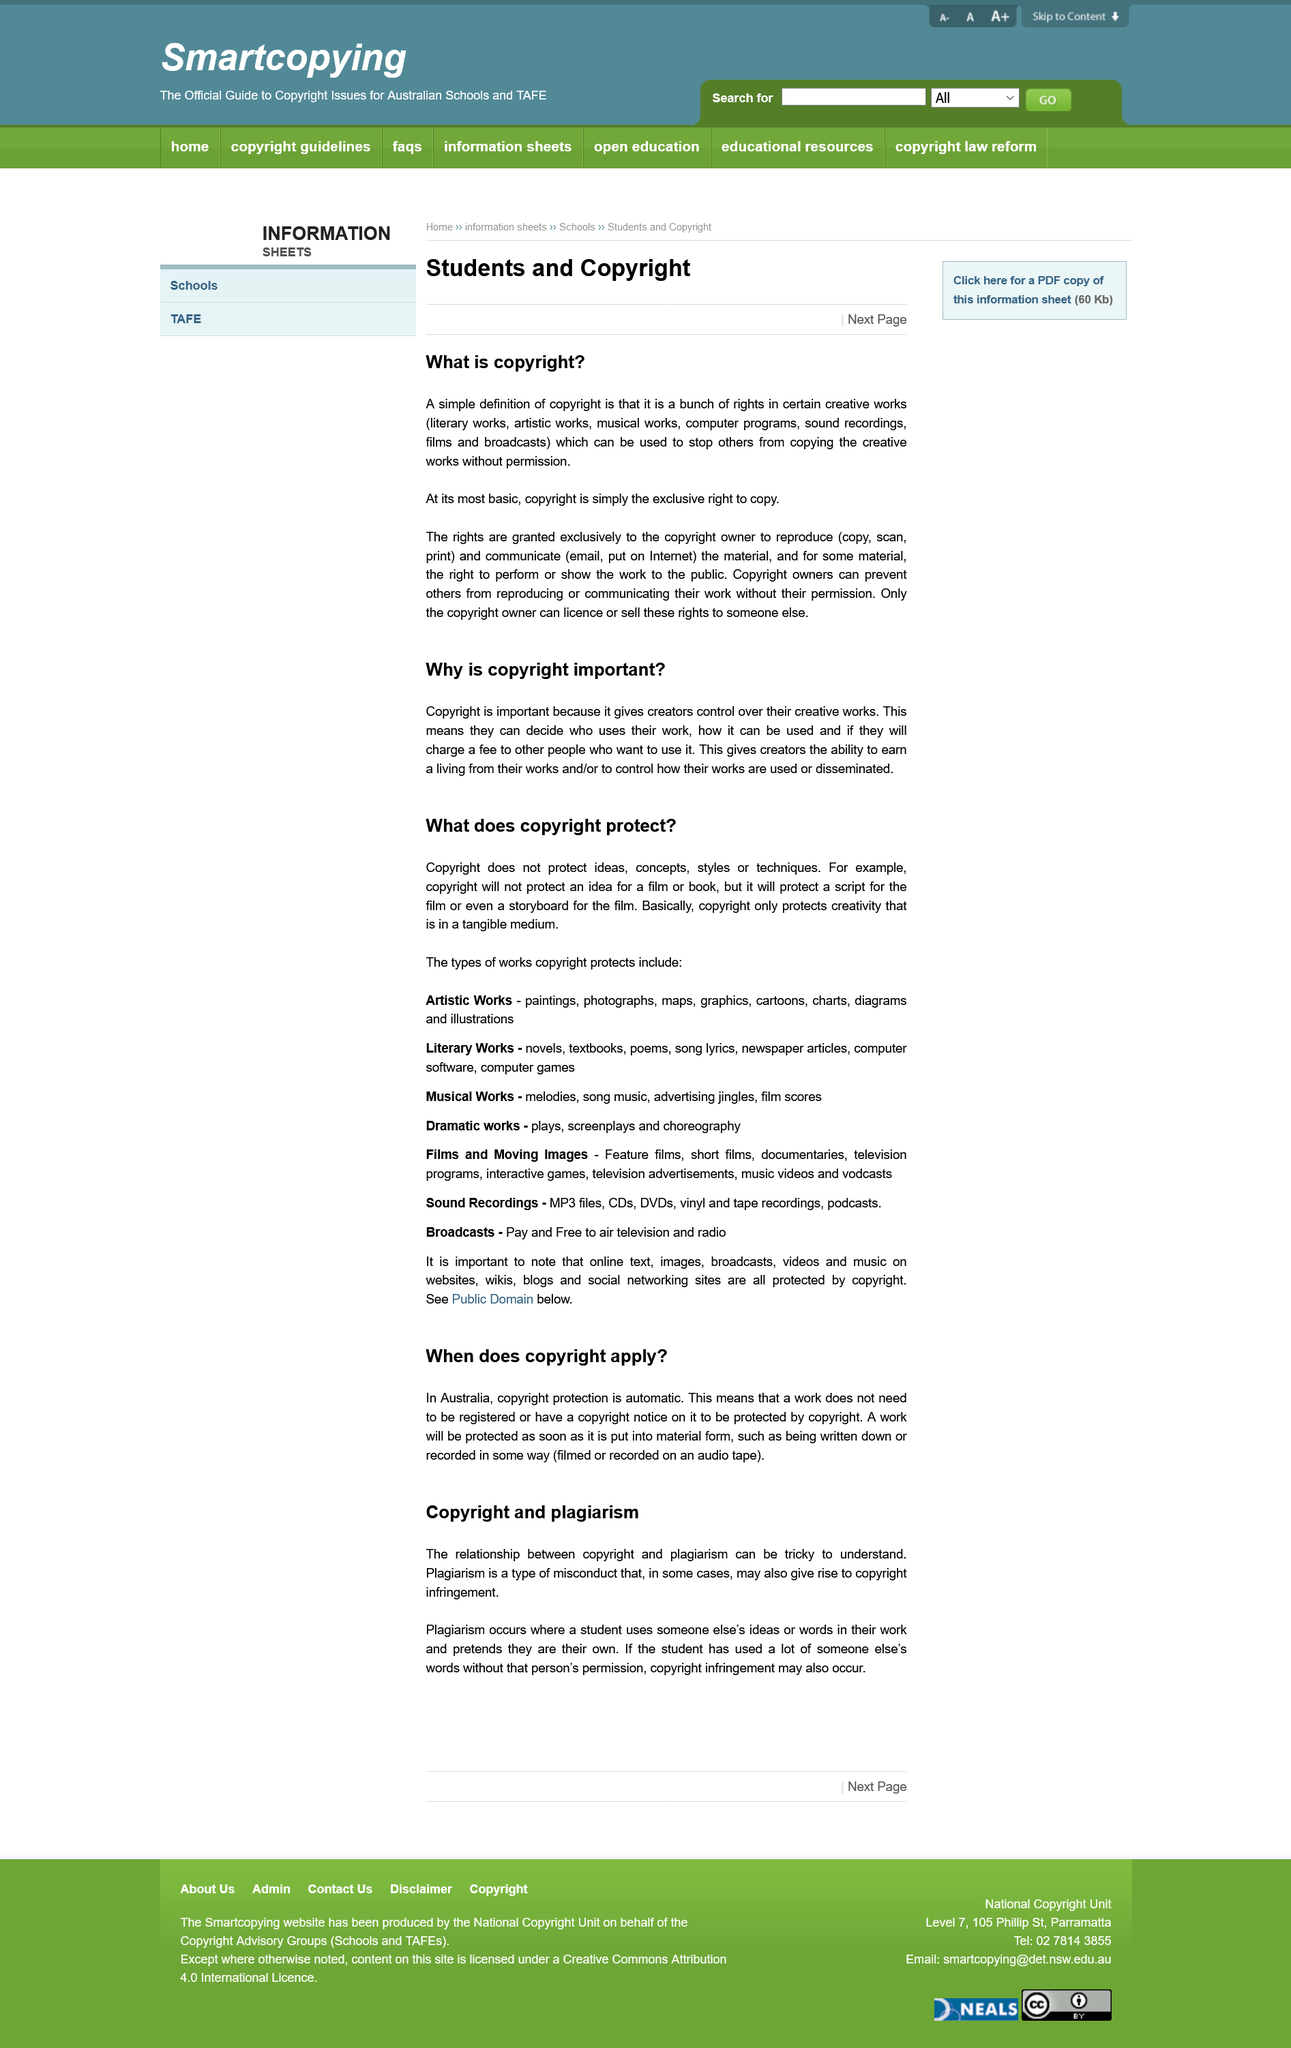Highlight a few significant elements in this photo. Copyright applies to a work regardless of whether it is registered or not, it is automatic. Copyright protection is automatic in Australia, and it applies to all original works, including literary, dramatic, musical, and artistic works, sound recordings, and films. Copyright is the exclusive right to copy and reproduce a work, as well as the right to distribute, display, and perform it, in order to protect the original creator's rights and prevent unauthorized usage. Declarative sentence: "The control over creative works means that the creators have the authority to decide who can use their work, how it can be utilized, and if they will charge a fee for others to access it. Copyright does not protect ideas, concepts, styles, or techniques. 